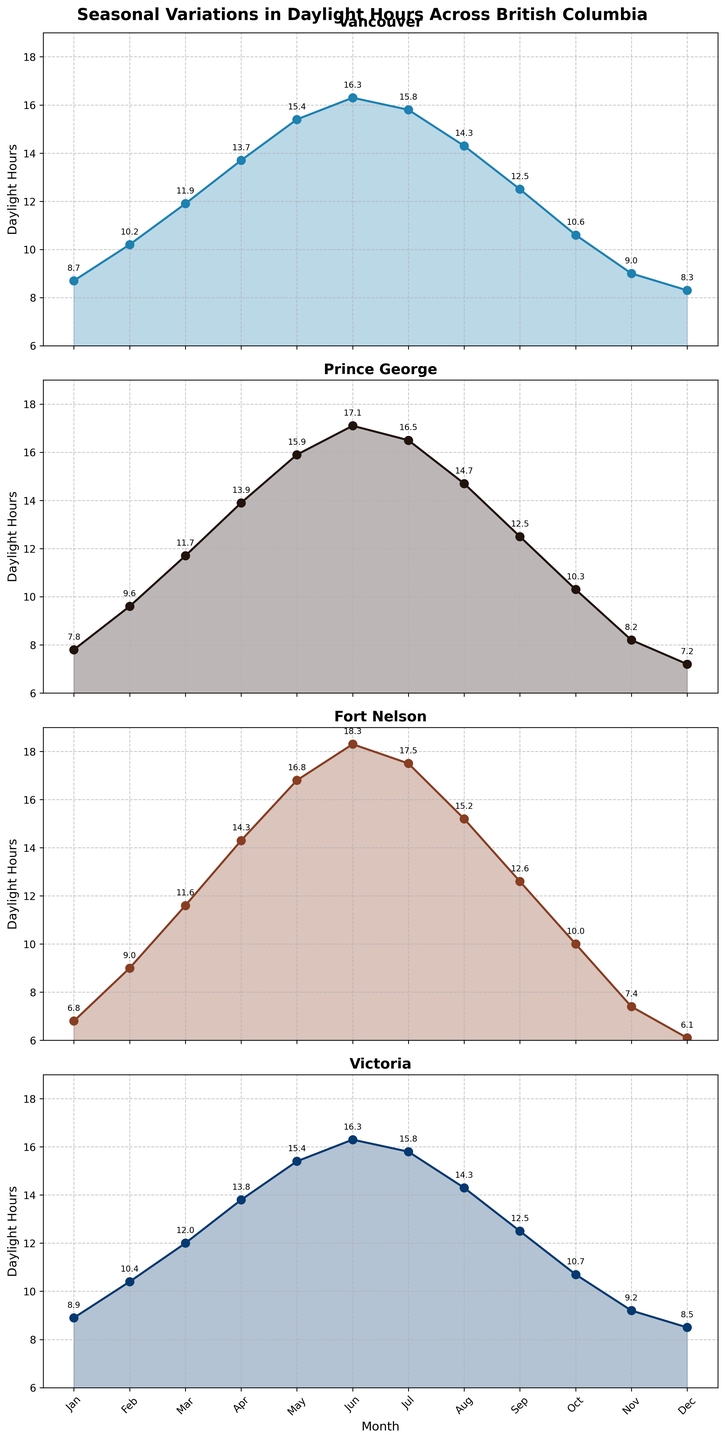What month has the highest daylight hours in Fort Nelson? The highest point on the Fort Nelson plot is in June with 18.3 hours.
Answer: June Which city has the least daylight hours in December? In December, Fort Nelson has 6.1 hours, which is lower than 7.2 hours for Prince George, 8.3 hours for Vancouver, and 8.5 hours for Victoria.
Answer: Fort Nelson How does daylight in Prince George compare between January and February? In January, Prince George has 7.8 hours and in February it has 9.6 hours, an increase of 1.8 hours.
Answer: 9.6 hours in February is more than 7.8 hours in January by 1.8 hours Which two cities have equal daylight hours in September? Both Vancouver and Victoria have 12.5 hours of daylight in September.
Answer: Vancouver and Victoria What is the average daylight hours in May across all cities? Sum the daylight hours for Vancouver (15.4), Prince George (15.9), Fort Nelson (16.8), and Victoria (15.4), then divide by 4: (15.4 + 15.9 + 16.8 + 15.4) / 4 = 63.5 / 4 = 15.875.
Answer: 15.875 hours In which months does Victoria have more daylight hours than Vancouver? Victoria has more daylight hours than Vancouver in January (8.9 vs 8.7), February (10.4 vs 10.2), March (12.0 vs 11.9), October (10.7 vs 10.6), and November (9.2 vs 9.0).
Answer: January, February, March, October, November Which city experiences the smallest variation in daylight hours throughout the year? Look for the city with the smallest difference between its maximum and minimum daylight hours. Vancouver ranges from 8.3 to 16.3 hours (8.0 difference), Prince George from 7.2 to 17.1 (9.9 difference), Fort Nelson from 6.1 to 18.3 (12.2 difference), and Victoria from 8.5 to 16.3 (7.8 difference).
Answer: Victoria How does the range of daylight hours in Fort Nelson compare to Vancouver? The range in Fort Nelson is 6.1 to 18.3 (12.2) and in Vancouver 8.3 to 16.3 (8.0), so Fort Nelson has a larger range by 4.2 hours.
Answer: Fort Nelson has a larger range by 4.2 hours What is the median daylight hours in July for all cities? Jul has daylight hours of Vancouver (15.8), Prince George (16.5), Fort Nelson (17.5), Victoria (15.8). The median of 15.8, 15.8, 16.5, and 17.5 is the average of 15.8 and 16.5, which is (15.8 + 16.5) / 2 = 16.15.
Answer: 16.15 hours 